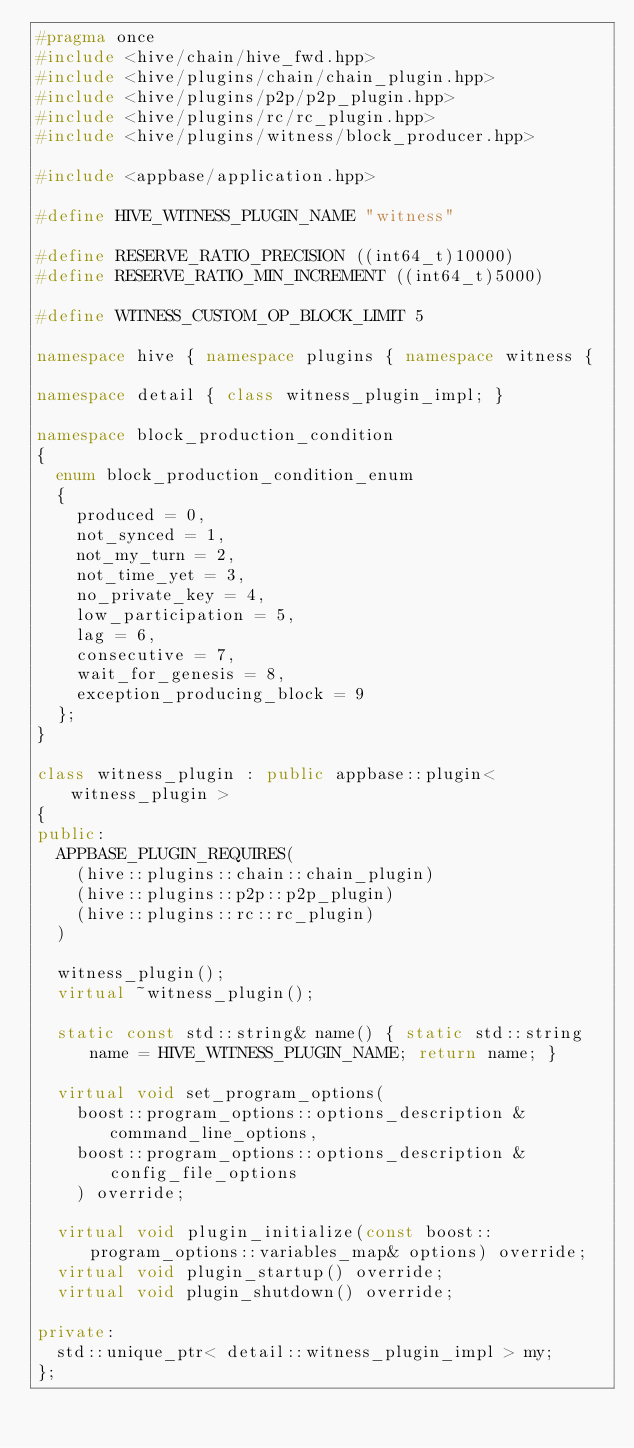Convert code to text. <code><loc_0><loc_0><loc_500><loc_500><_C++_>#pragma once
#include <hive/chain/hive_fwd.hpp>
#include <hive/plugins/chain/chain_plugin.hpp>
#include <hive/plugins/p2p/p2p_plugin.hpp>
#include <hive/plugins/rc/rc_plugin.hpp>
#include <hive/plugins/witness/block_producer.hpp>

#include <appbase/application.hpp>

#define HIVE_WITNESS_PLUGIN_NAME "witness"

#define RESERVE_RATIO_PRECISION ((int64_t)10000)
#define RESERVE_RATIO_MIN_INCREMENT ((int64_t)5000)

#define WITNESS_CUSTOM_OP_BLOCK_LIMIT 5

namespace hive { namespace plugins { namespace witness {

namespace detail { class witness_plugin_impl; }

namespace block_production_condition
{
  enum block_production_condition_enum
  {
    produced = 0,
    not_synced = 1,
    not_my_turn = 2,
    not_time_yet = 3,
    no_private_key = 4,
    low_participation = 5,
    lag = 6,
    consecutive = 7,
    wait_for_genesis = 8,
    exception_producing_block = 9
  };
}

class witness_plugin : public appbase::plugin< witness_plugin >
{
public:
  APPBASE_PLUGIN_REQUIRES(
    (hive::plugins::chain::chain_plugin)
    (hive::plugins::p2p::p2p_plugin)
    (hive::plugins::rc::rc_plugin)
  )

  witness_plugin();
  virtual ~witness_plugin();

  static const std::string& name() { static std::string name = HIVE_WITNESS_PLUGIN_NAME; return name; }

  virtual void set_program_options(
    boost::program_options::options_description &command_line_options,
    boost::program_options::options_description &config_file_options
    ) override;

  virtual void plugin_initialize(const boost::program_options::variables_map& options) override;
  virtual void plugin_startup() override;
  virtual void plugin_shutdown() override;

private:
  std::unique_ptr< detail::witness_plugin_impl > my;
};
</code> 